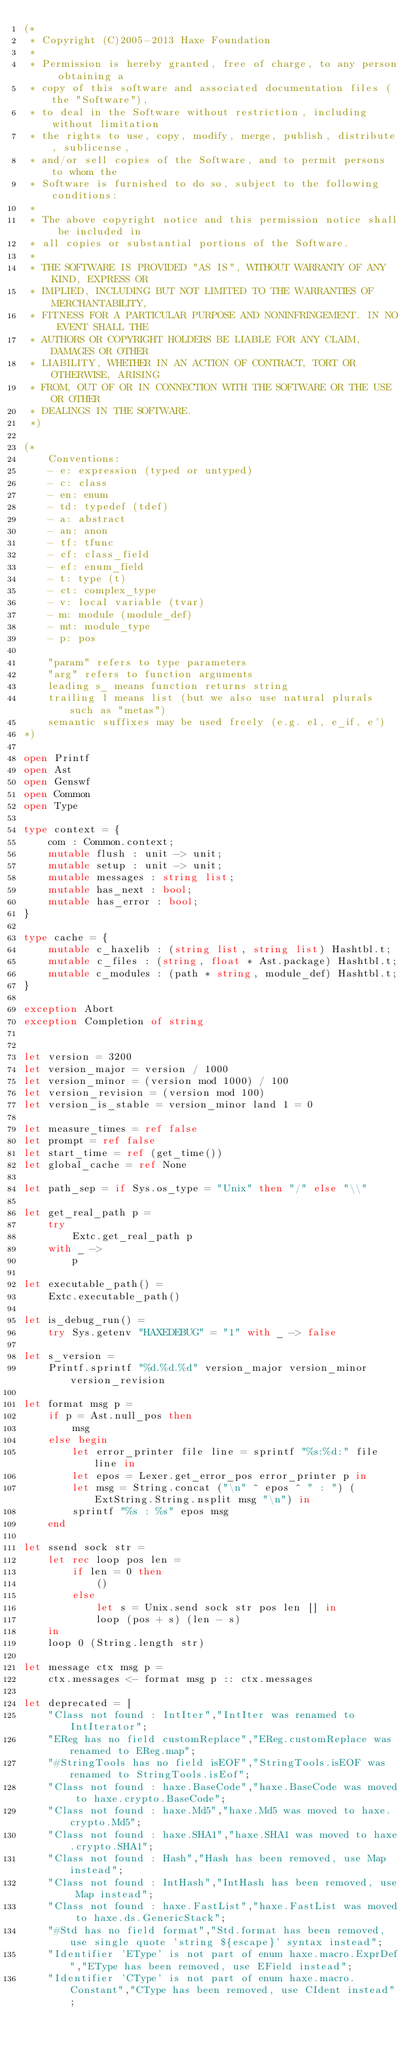<code> <loc_0><loc_0><loc_500><loc_500><_OCaml_>(*
 * Copyright (C)2005-2013 Haxe Foundation
 *
 * Permission is hereby granted, free of charge, to any person obtaining a
 * copy of this software and associated documentation files (the "Software"),
 * to deal in the Software without restriction, including without limitation
 * the rights to use, copy, modify, merge, publish, distribute, sublicense,
 * and/or sell copies of the Software, and to permit persons to whom the
 * Software is furnished to do so, subject to the following conditions:
 *
 * The above copyright notice and this permission notice shall be included in
 * all copies or substantial portions of the Software.
 *
 * THE SOFTWARE IS PROVIDED "AS IS", WITHOUT WARRANTY OF ANY KIND, EXPRESS OR
 * IMPLIED, INCLUDING BUT NOT LIMITED TO THE WARRANTIES OF MERCHANTABILITY,
 * FITNESS FOR A PARTICULAR PURPOSE AND NONINFRINGEMENT. IN NO EVENT SHALL THE
 * AUTHORS OR COPYRIGHT HOLDERS BE LIABLE FOR ANY CLAIM, DAMAGES OR OTHER
 * LIABILITY, WHETHER IN AN ACTION OF CONTRACT, TORT OR OTHERWISE, ARISING
 * FROM, OUT OF OR IN CONNECTION WITH THE SOFTWARE OR THE USE OR OTHER
 * DEALINGS IN THE SOFTWARE.
 *)

(*
	Conventions:
	- e: expression (typed or untyped)
	- c: class
	- en: enum
	- td: typedef (tdef)
	- a: abstract
	- an: anon
	- tf: tfunc
	- cf: class_field
	- ef: enum_field
	- t: type (t)
	- ct: complex_type
	- v: local variable (tvar)
	- m: module (module_def)
	- mt: module_type
	- p: pos

	"param" refers to type parameters
	"arg" refers to function arguments
	leading s_ means function returns string
	trailing l means list (but we also use natural plurals such as "metas")
	semantic suffixes may be used freely (e.g. e1, e_if, e')
*)

open Printf
open Ast
open Genswf
open Common
open Type

type context = {
	com : Common.context;
	mutable flush : unit -> unit;
	mutable setup : unit -> unit;
	mutable messages : string list;
	mutable has_next : bool;
	mutable has_error : bool;
}

type cache = {
	mutable c_haxelib : (string list, string list) Hashtbl.t;
	mutable c_files : (string, float * Ast.package) Hashtbl.t;
	mutable c_modules : (path * string, module_def) Hashtbl.t;
}

exception Abort
exception Completion of string


let version = 3200
let version_major = version / 1000
let version_minor = (version mod 1000) / 100
let version_revision = (version mod 100)
let version_is_stable = version_minor land 1 = 0

let measure_times = ref false
let prompt = ref false
let start_time = ref (get_time())
let global_cache = ref None

let path_sep = if Sys.os_type = "Unix" then "/" else "\\"

let get_real_path p =
	try
		Extc.get_real_path p
	with _ ->
		p

let executable_path() =
	Extc.executable_path()

let is_debug_run() =
	try Sys.getenv "HAXEDEBUG" = "1" with _ -> false

let s_version =
	Printf.sprintf "%d.%d.%d" version_major version_minor version_revision

let format msg p =
	if p = Ast.null_pos then
		msg
	else begin
		let error_printer file line = sprintf "%s:%d:" file line in
		let epos = Lexer.get_error_pos error_printer p in
		let msg = String.concat ("\n" ^ epos ^ " : ") (ExtString.String.nsplit msg "\n") in
		sprintf "%s : %s" epos msg
	end

let ssend sock str =
	let rec loop pos len =
		if len = 0 then
			()
		else
			let s = Unix.send sock str pos len [] in
			loop (pos + s) (len - s)
	in
	loop 0 (String.length str)

let message ctx msg p =
	ctx.messages <- format msg p :: ctx.messages

let deprecated = [
	"Class not found : IntIter","IntIter was renamed to IntIterator";
	"EReg has no field customReplace","EReg.customReplace was renamed to EReg.map";
	"#StringTools has no field isEOF","StringTools.isEOF was renamed to StringTools.isEof";
	"Class not found : haxe.BaseCode","haxe.BaseCode was moved to haxe.crypto.BaseCode";
	"Class not found : haxe.Md5","haxe.Md5 was moved to haxe.crypto.Md5";
	"Class not found : haxe.SHA1","haxe.SHA1 was moved to haxe.crypto.SHA1";
	"Class not found : Hash","Hash has been removed, use Map instead";
	"Class not found : IntHash","IntHash has been removed, use Map instead";
	"Class not found : haxe.FastList","haxe.FastList was moved to haxe.ds.GenericStack";
	"#Std has no field format","Std.format has been removed, use single quote 'string ${escape}' syntax instead";
	"Identifier 'EType' is not part of enum haxe.macro.ExprDef","EType has been removed, use EField instead";
	"Identifier 'CType' is not part of enum haxe.macro.Constant","CType has been removed, use CIdent instead";</code> 